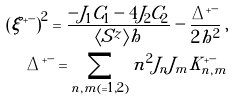<formula> <loc_0><loc_0><loc_500><loc_500>& & \left ( \xi ^ { + - } \right ) ^ { 2 } = \frac { - J _ { 1 } C _ { 1 } - 4 J _ { 2 } C _ { 2 } } { \langle S ^ { z } \rangle h } - \frac { \Delta ^ { + - } } { 2 h ^ { 2 } } \, , \\ & & \Delta ^ { + - } = \sum _ { n , m ( = 1 , 2 ) } n ^ { 2 } J _ { n } J _ { m } K _ { n , m } ^ { + - }</formula> 